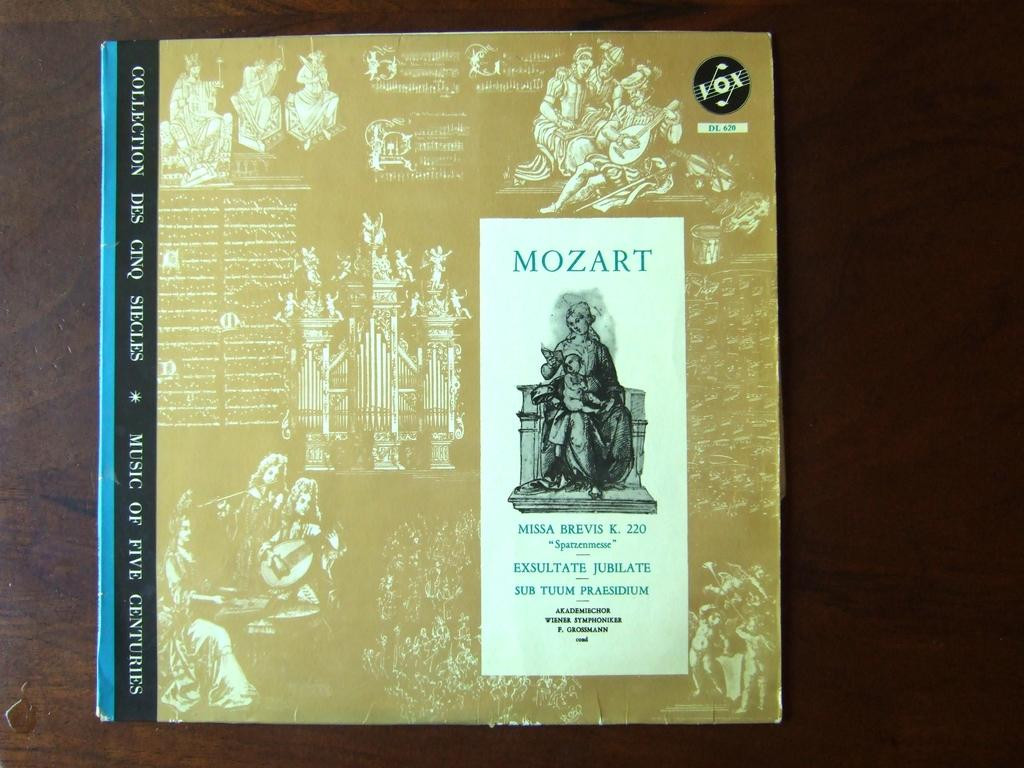Provide a one-sentence caption for the provided image. a booklet of mozart it looks like its a music book. 